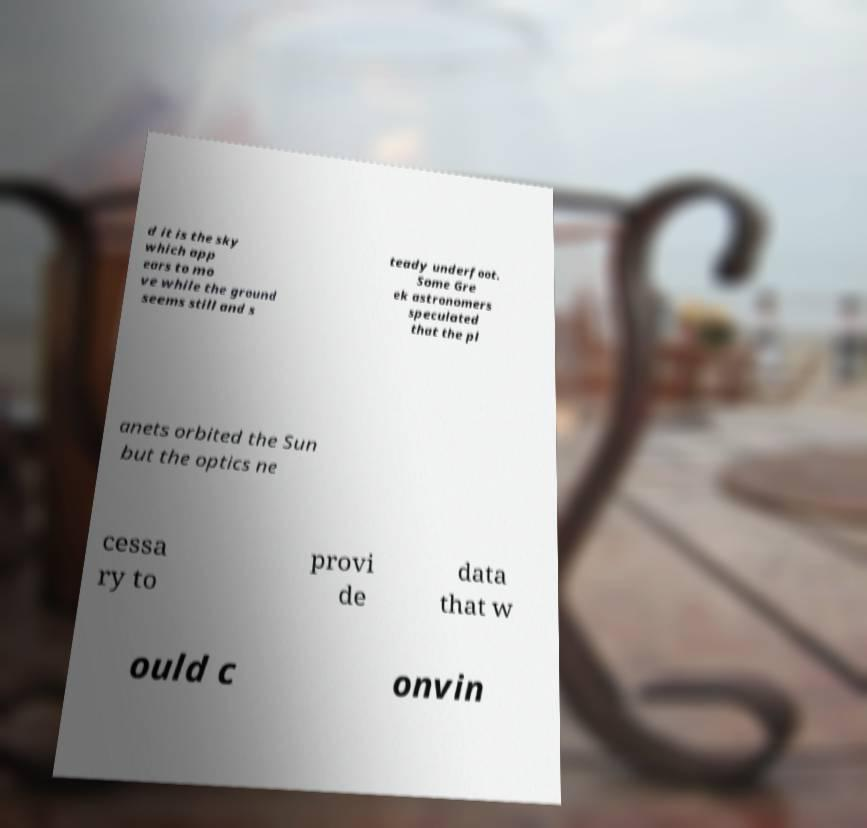Please identify and transcribe the text found in this image. d it is the sky which app ears to mo ve while the ground seems still and s teady underfoot. Some Gre ek astronomers speculated that the pl anets orbited the Sun but the optics ne cessa ry to provi de data that w ould c onvin 